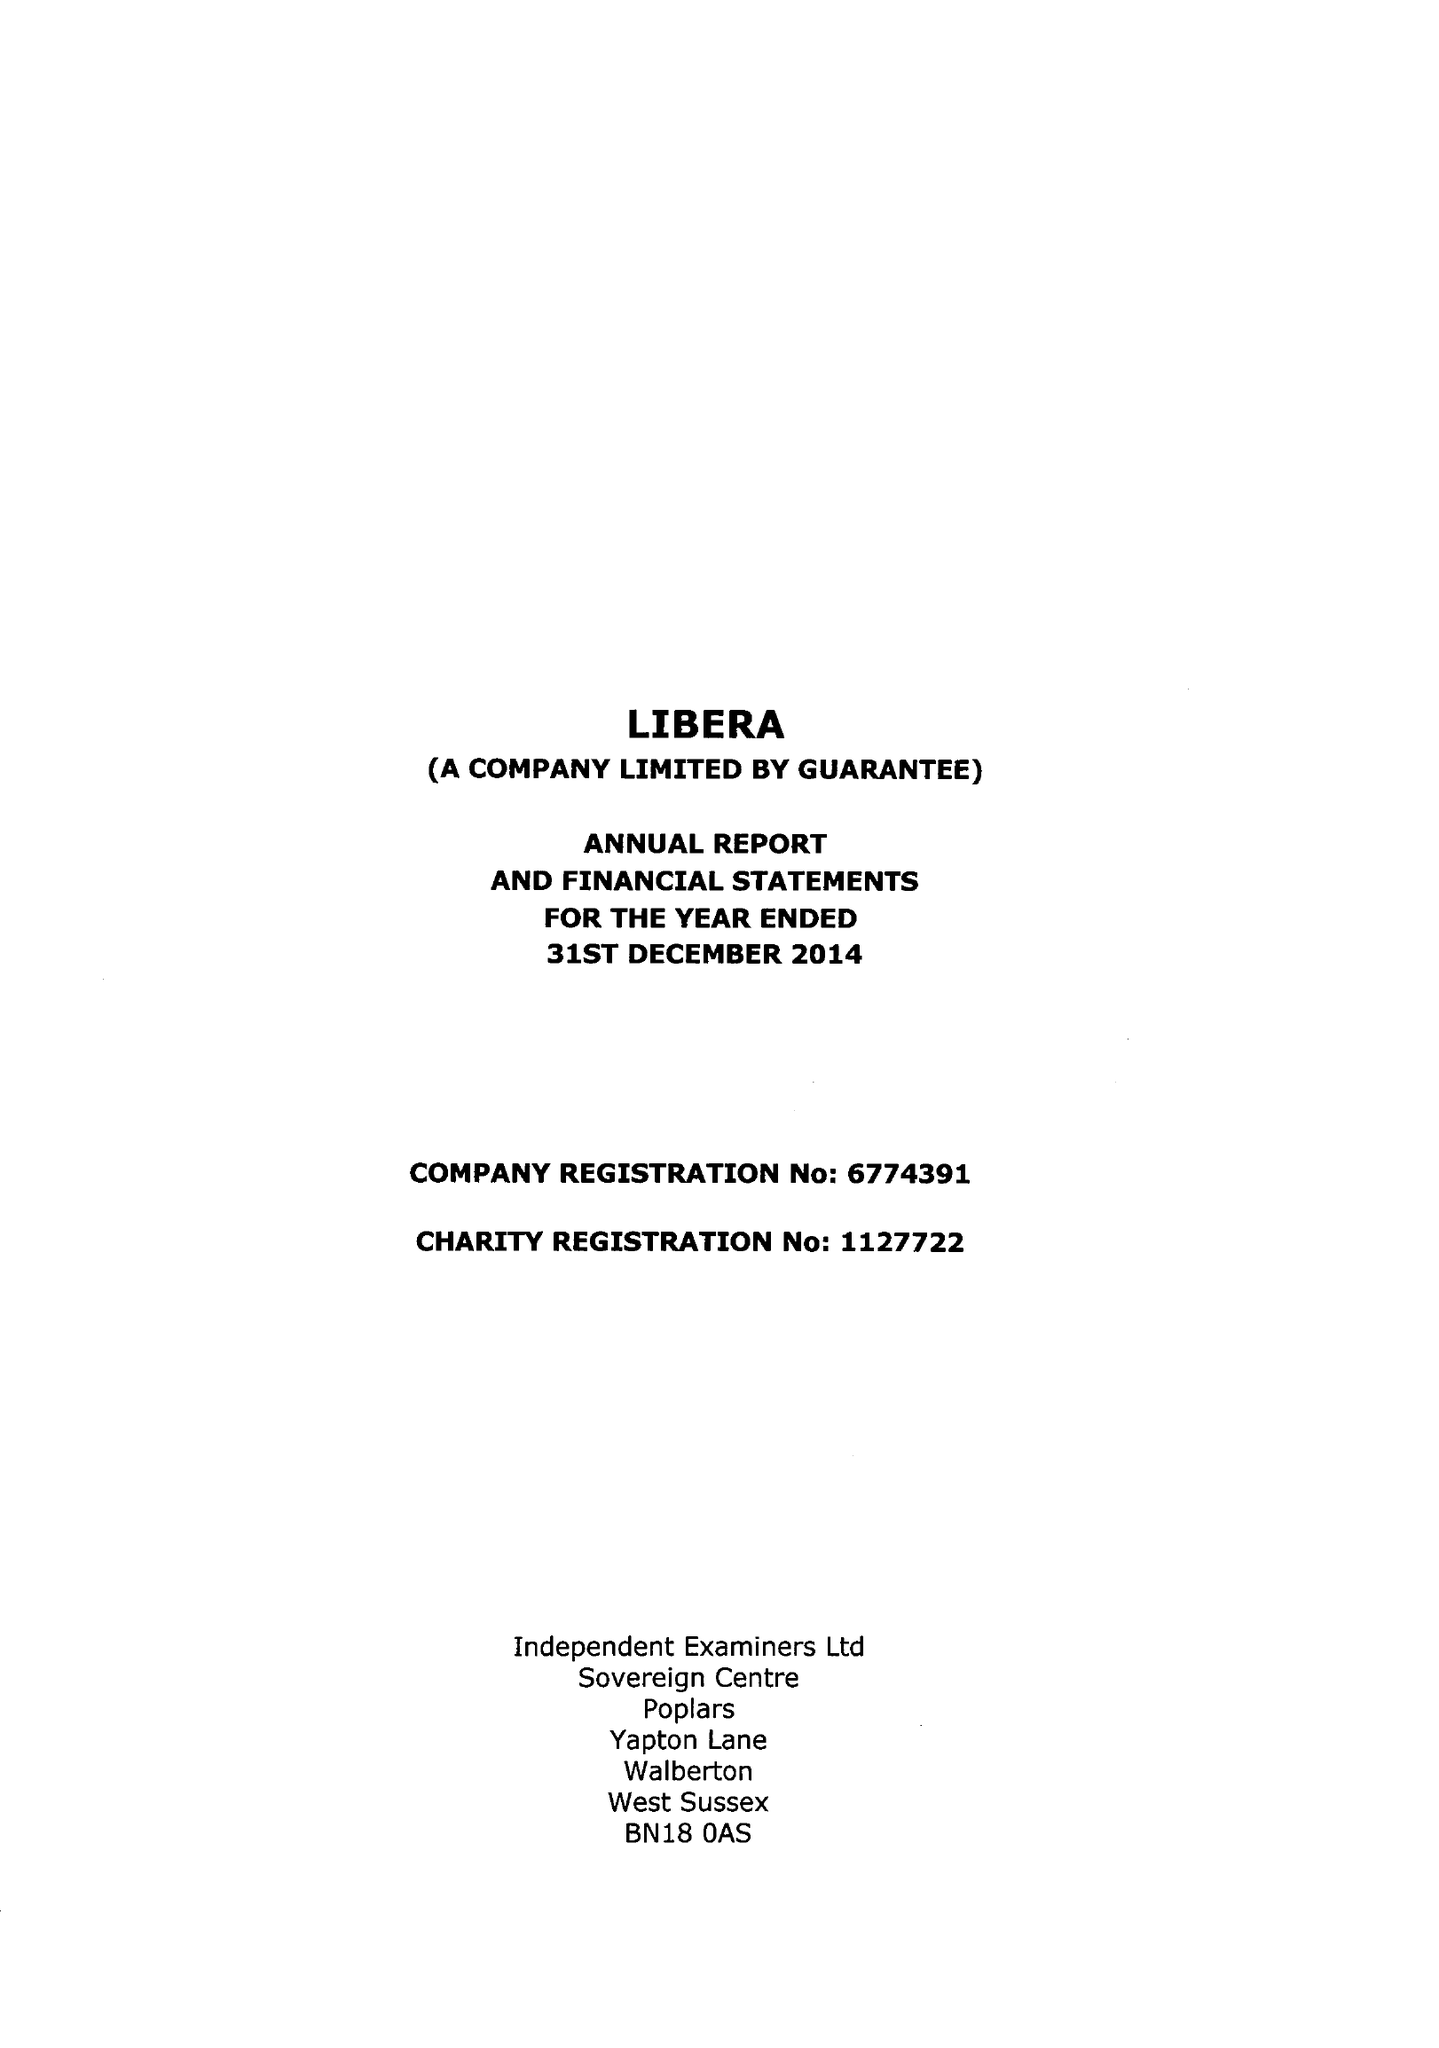What is the value for the report_date?
Answer the question using a single word or phrase. 2014-12-31 